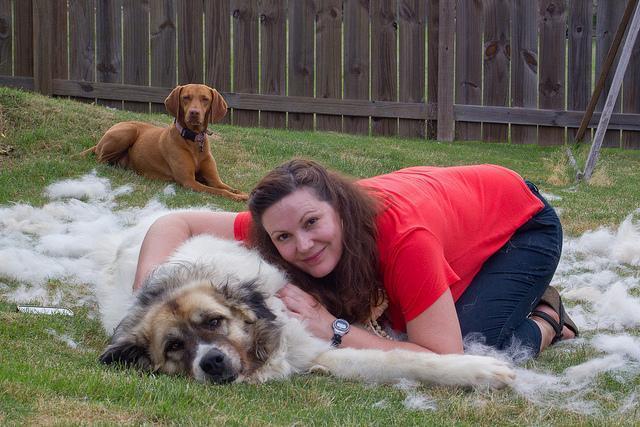How many dogs are there?
Give a very brief answer. 2. 